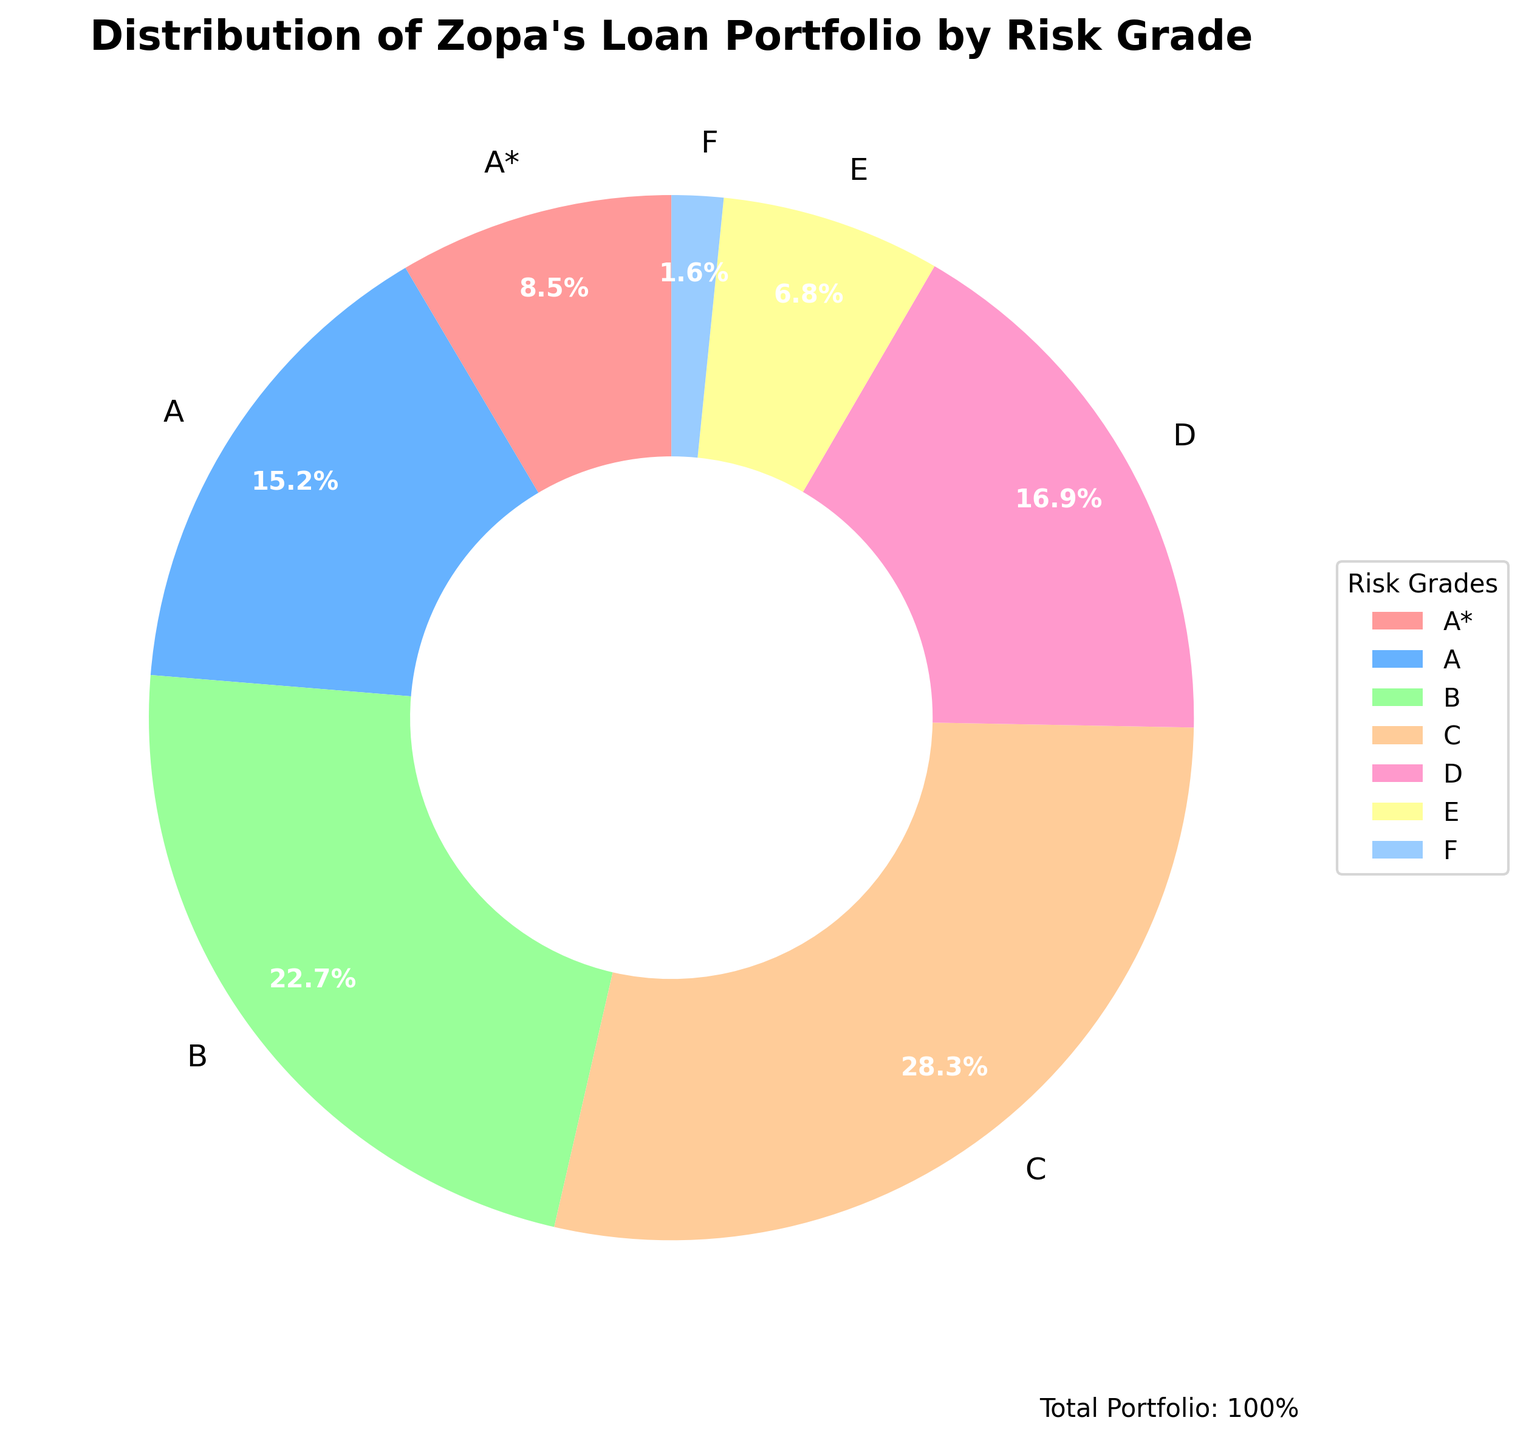What percentage of Zopa's loan portfolio constitutes the 'B' risk grade? Locate the segment labeled 'B' on the pie chart, then read the percentage value indicated on the chart.
Answer: 22.7% Which risk grade has the highest percentage in Zopa's loan portfolio? Observe the pie chart to determine which segment covers the largest area, representing the highest percentage.
Answer: C What is the combined percentage of risk grades 'A*' and 'E'? Find the percentages for 'A*' and 'E', which are 8.5% and 6.8% respectively. Add these values: 8.5% + 6.8% = 15.3%.
Answer: 15.3% How much larger is the percentage for risk grade 'C' compared to 'F'? Identify the percentages for 'C' and 'F', which are 28.3% and 1.6% respectively. Subtract the smaller percentage from the larger: 28.3% - 1.6% = 26.7%.
Answer: 26.7% Which risk grade has the smallest representation in Zopa's loan portfolio? Look at the pie chart to find the smallest segment, which represents the smallest percentage.
Answer: F What colors are used to represent risk grades 'A' and 'D' on the pie chart? Identify the segments labeled 'A' and 'D' on the pie chart and note the colors of these segments.
Answer: Blue and peach Are the percentages of risk grades 'A' and 'D' equal? If not, which is greater? Compare the percentages for 'A' (15.2%) and 'D' (16.9%) on the pie chart. Determine which is greater.
Answer: D How do the percentages of risk grades 'C' and 'F' compare in terms of their visual representation on the pie chart? Observe the visual difference in the pie chart segments for 'C' and 'F'. The larger segment for 'C' indicates a higher percentage.
Answer: C is significantly larger 